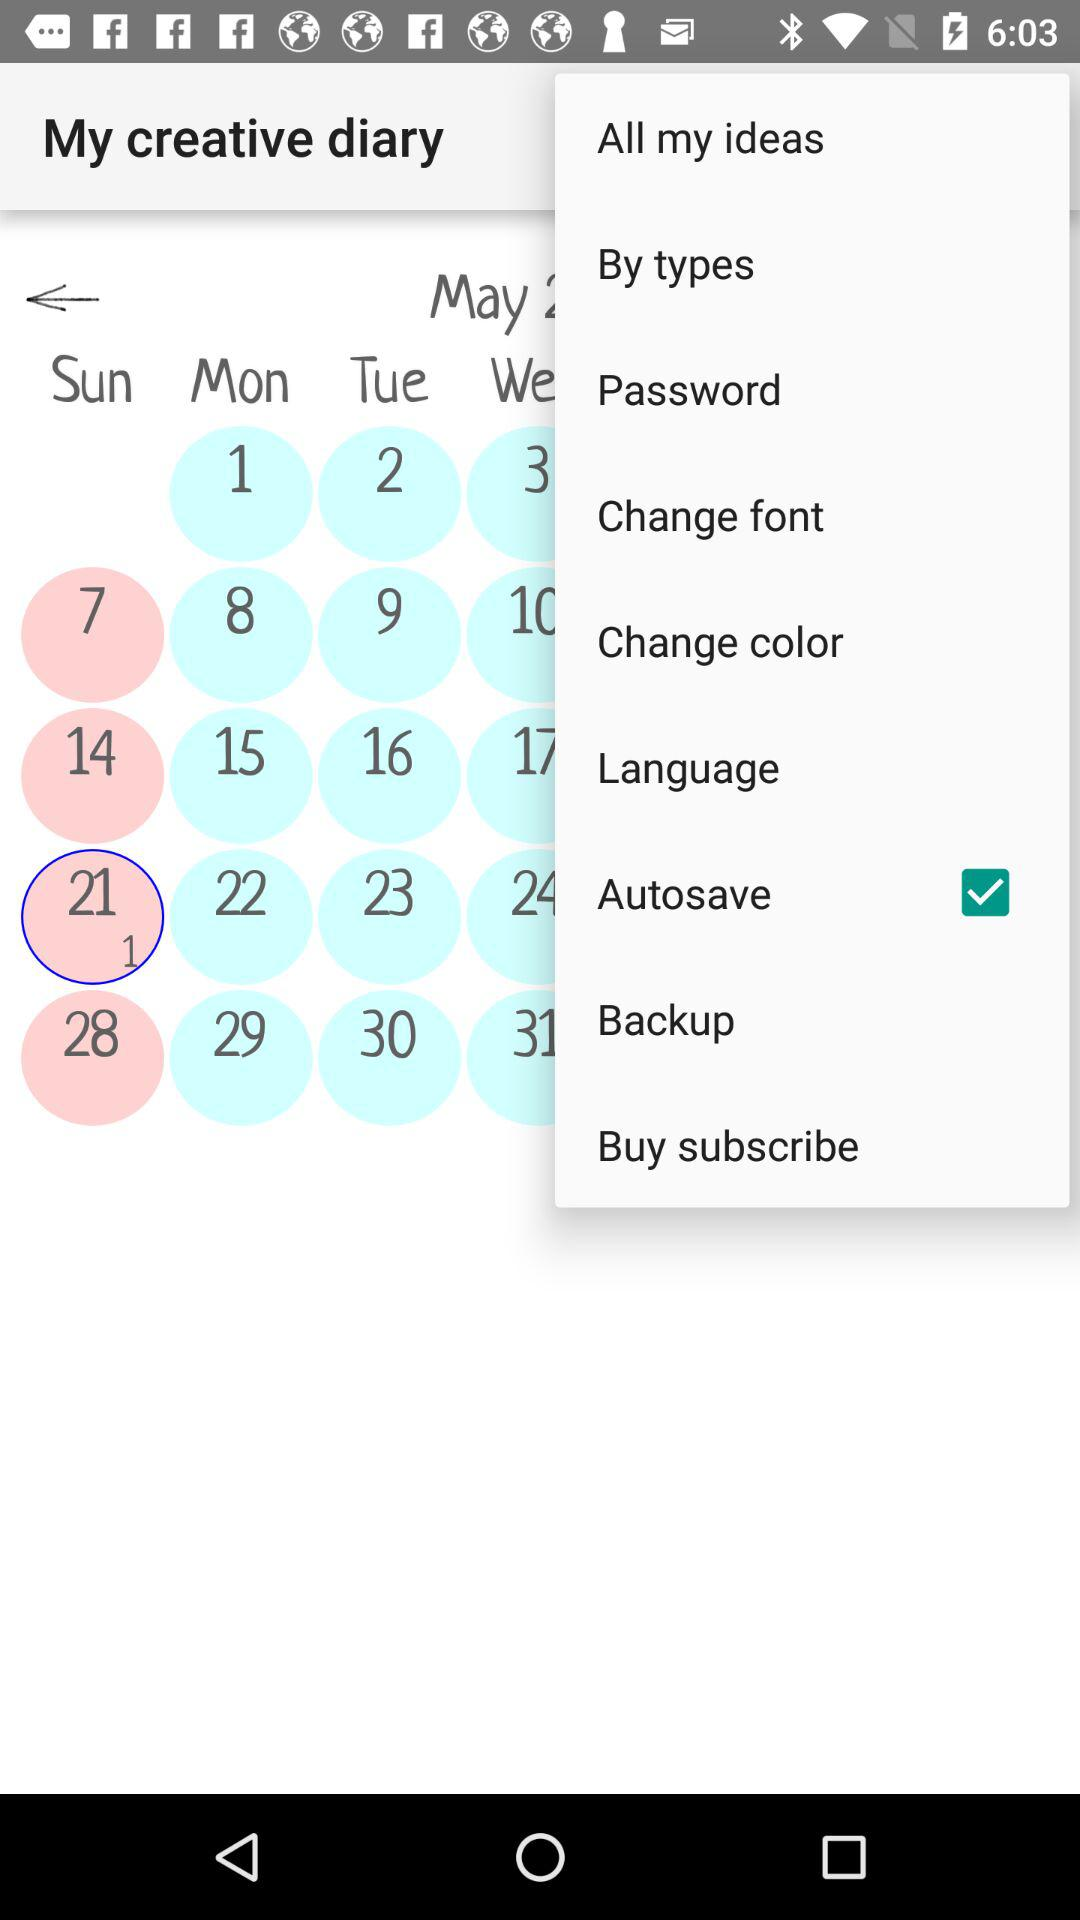Which option is checked? The checked option is "Autosave". 